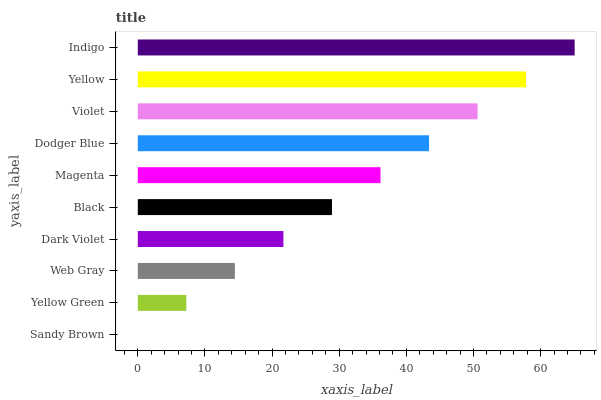Is Sandy Brown the minimum?
Answer yes or no. Yes. Is Indigo the maximum?
Answer yes or no. Yes. Is Yellow Green the minimum?
Answer yes or no. No. Is Yellow Green the maximum?
Answer yes or no. No. Is Yellow Green greater than Sandy Brown?
Answer yes or no. Yes. Is Sandy Brown less than Yellow Green?
Answer yes or no. Yes. Is Sandy Brown greater than Yellow Green?
Answer yes or no. No. Is Yellow Green less than Sandy Brown?
Answer yes or no. No. Is Magenta the high median?
Answer yes or no. Yes. Is Black the low median?
Answer yes or no. Yes. Is Yellow the high median?
Answer yes or no. No. Is Indigo the low median?
Answer yes or no. No. 